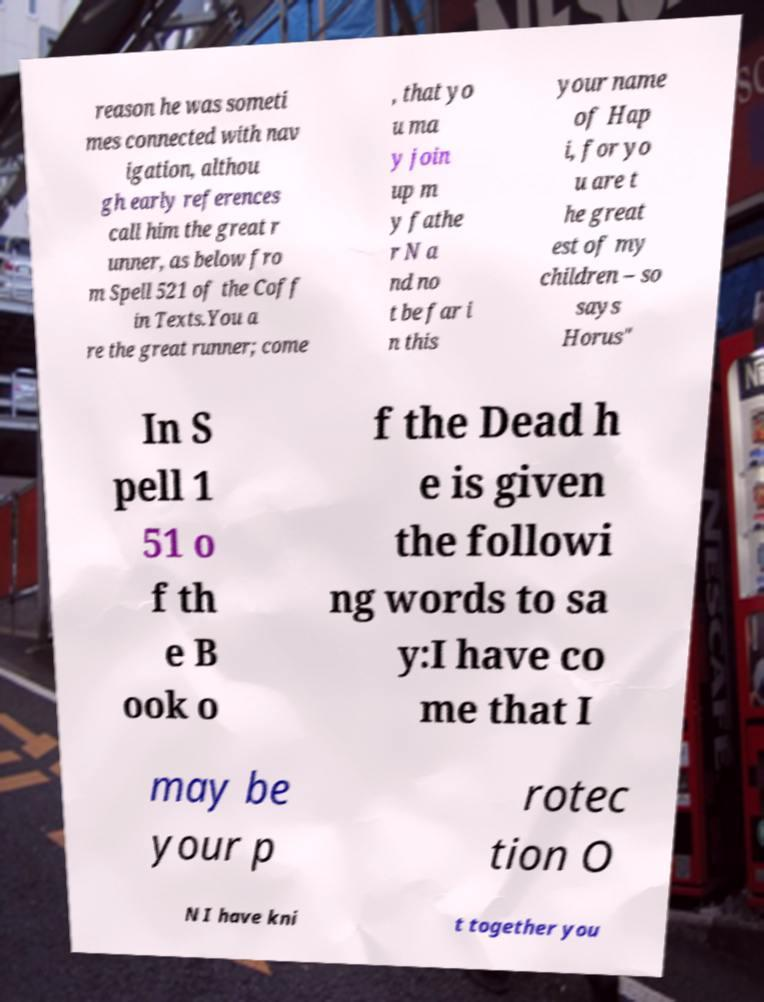Please read and relay the text visible in this image. What does it say? reason he was someti mes connected with nav igation, althou gh early references call him the great r unner, as below fro m Spell 521 of the Coff in Texts.You a re the great runner; come , that yo u ma y join up m y fathe r N a nd no t be far i n this your name of Hap i, for yo u are t he great est of my children – so says Horus" In S pell 1 51 o f th e B ook o f the Dead h e is given the followi ng words to sa y:I have co me that I may be your p rotec tion O N I have kni t together you 